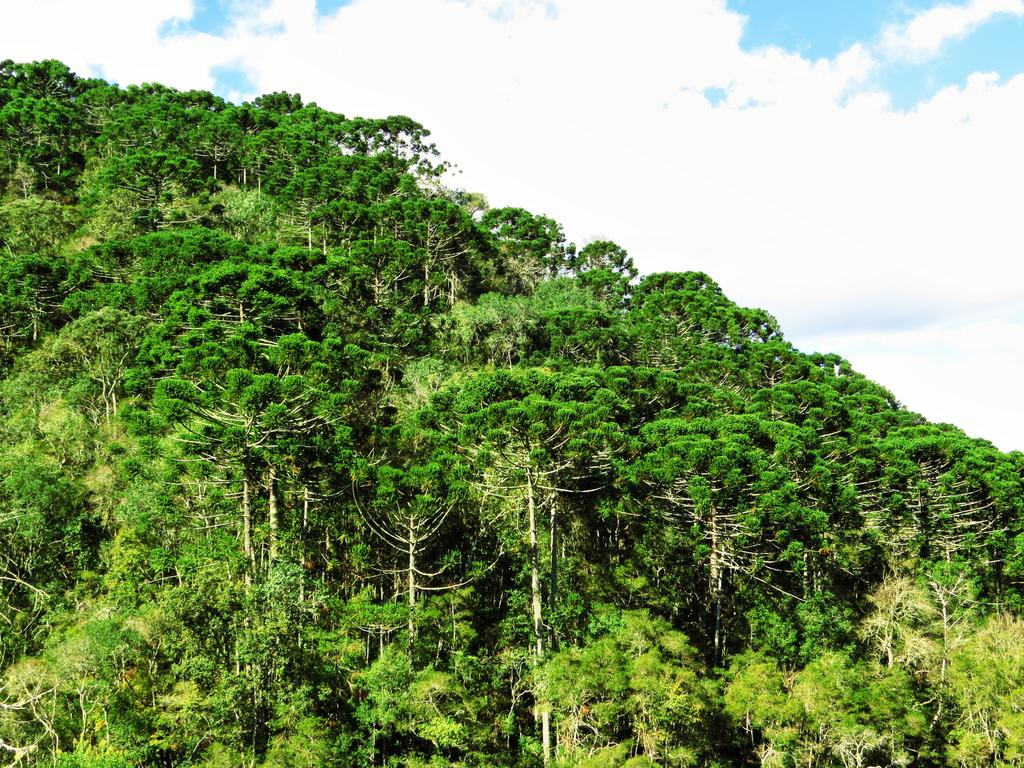Where was the image taken? The image was clicked outside the city. What can be seen in the foreground of the image? There are many trees in the foreground of the image. What is visible in the background of the image? There is a sky visible in the background of the image. What can be observed in the sky? Clouds are present in the sky. What type of zinc is present in the image? There is no zinc present in the image. How many people are sleeping in the image? There are no people visible in the image, so it cannot be determined if anyone is sleeping. 